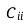<formula> <loc_0><loc_0><loc_500><loc_500>C _ { i i }</formula> 